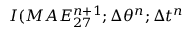<formula> <loc_0><loc_0><loc_500><loc_500>I ( M A E _ { 2 7 } ^ { n + 1 } ; \Delta \theta ^ { n } ; \Delta t ^ { n }</formula> 